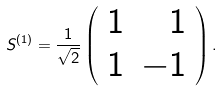Convert formula to latex. <formula><loc_0><loc_0><loc_500><loc_500>S ^ { ( 1 ) } = \frac { 1 } { \sqrt { 2 } } \left ( \begin{array} { l r } { 1 } & { 1 } \\ { 1 } & { - 1 } \end{array} \right ) .</formula> 